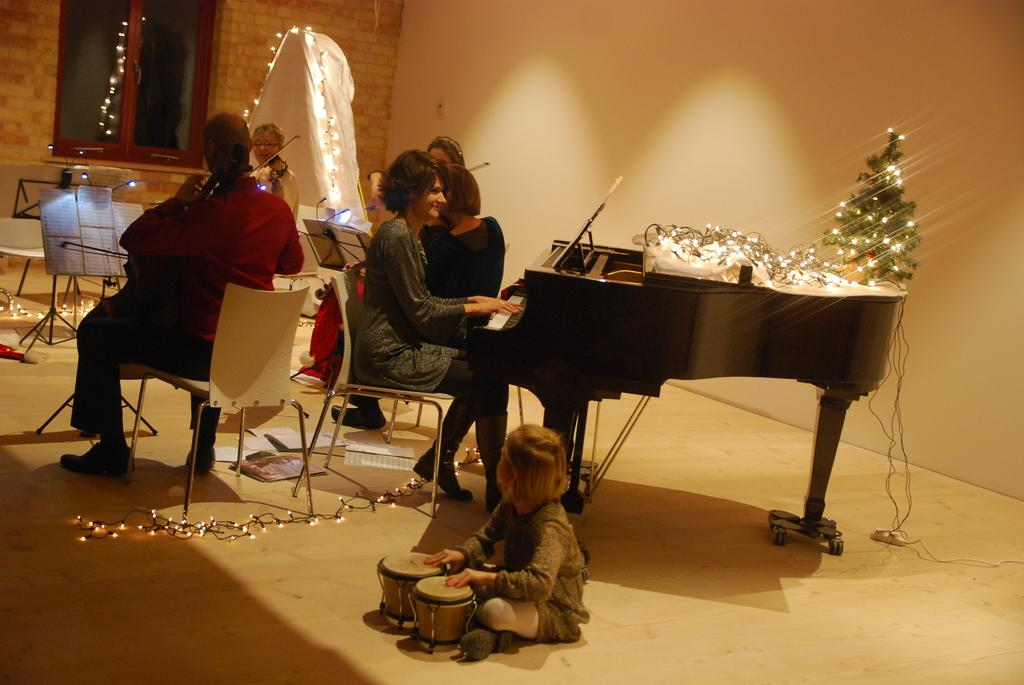Who is present in the image? There are people in the image. What are the people doing in the image? The people are sitting on chairs and playing musical instruments. What type of holiday is being celebrated by the maid in the image? There is no maid present in the image, and therefore no holiday can be associated with her. 